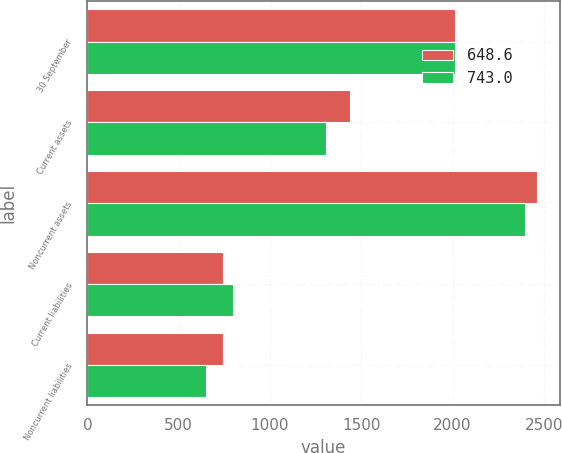Convert chart to OTSL. <chart><loc_0><loc_0><loc_500><loc_500><stacked_bar_chart><ecel><fcel>30 September<fcel>Current assets<fcel>Noncurrent assets<fcel>Current liabilities<fcel>Noncurrent liabilities<nl><fcel>648.6<fcel>2014<fcel>1440<fcel>2464.6<fcel>745.2<fcel>743<nl><fcel>743<fcel>2013<fcel>1307.9<fcel>2396.1<fcel>795.2<fcel>648.6<nl></chart> 